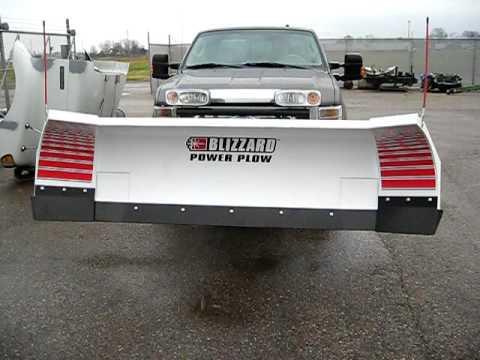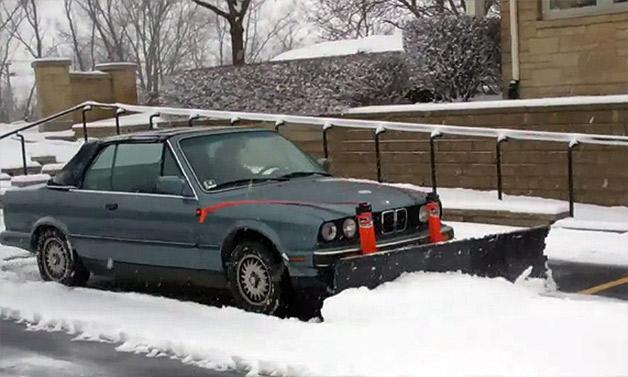The first image is the image on the left, the second image is the image on the right. Examine the images to the left and right. Is the description "Snow is being cleared by a vehicle." accurate? Answer yes or no. Yes. The first image is the image on the left, the second image is the image on the right. Assess this claim about the two images: "One image shows a vehicle pushing a plow through snow.". Correct or not? Answer yes or no. Yes. 